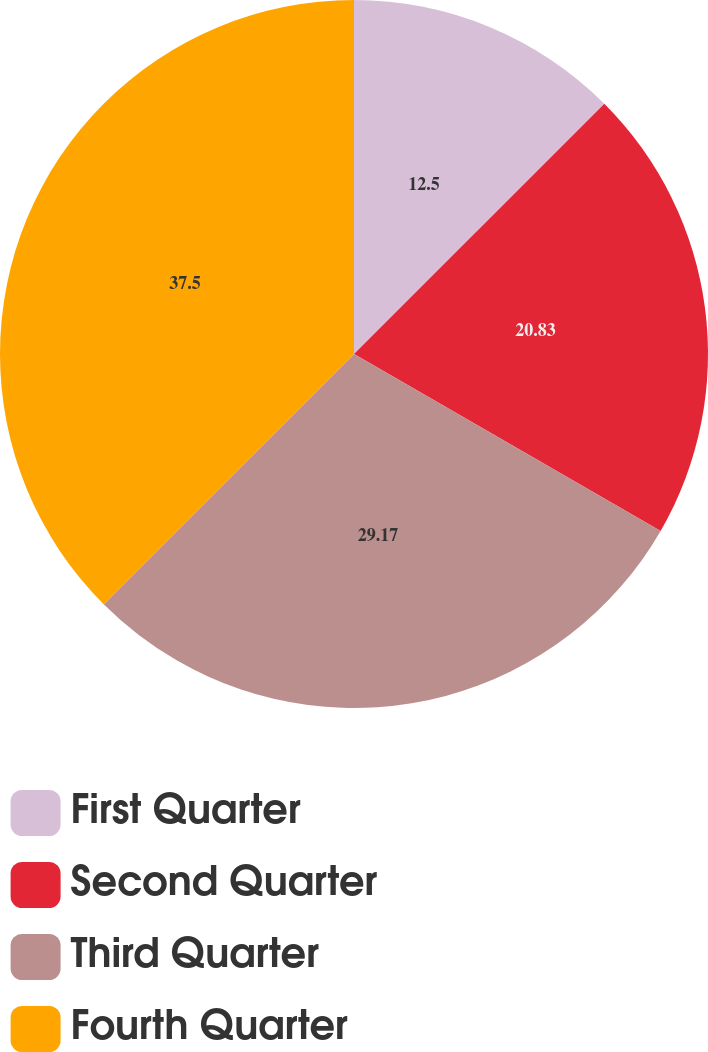Convert chart to OTSL. <chart><loc_0><loc_0><loc_500><loc_500><pie_chart><fcel>First Quarter<fcel>Second Quarter<fcel>Third Quarter<fcel>Fourth Quarter<nl><fcel>12.5%<fcel>20.83%<fcel>29.17%<fcel>37.5%<nl></chart> 